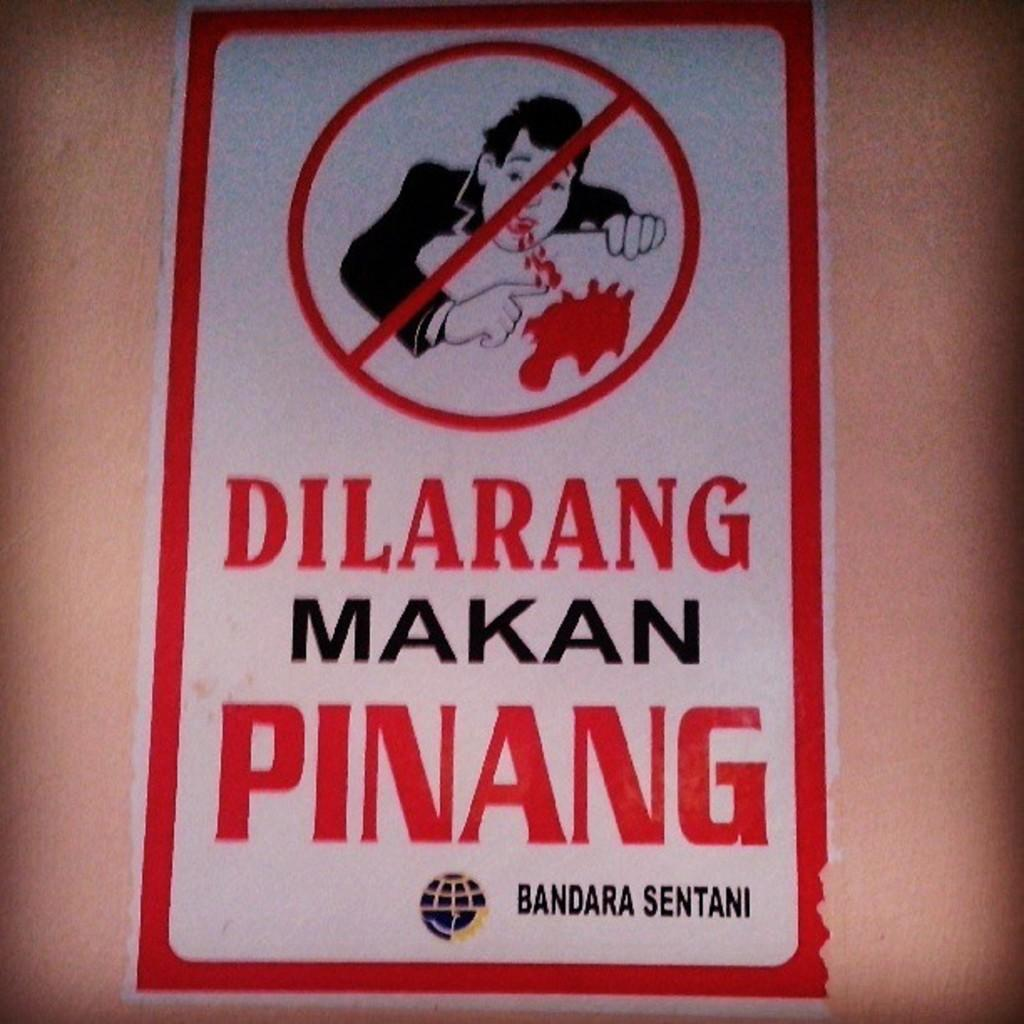<image>
Write a terse but informative summary of the picture. A sign that reads Dilarang Makan Pinang by Bandara Sentani. 